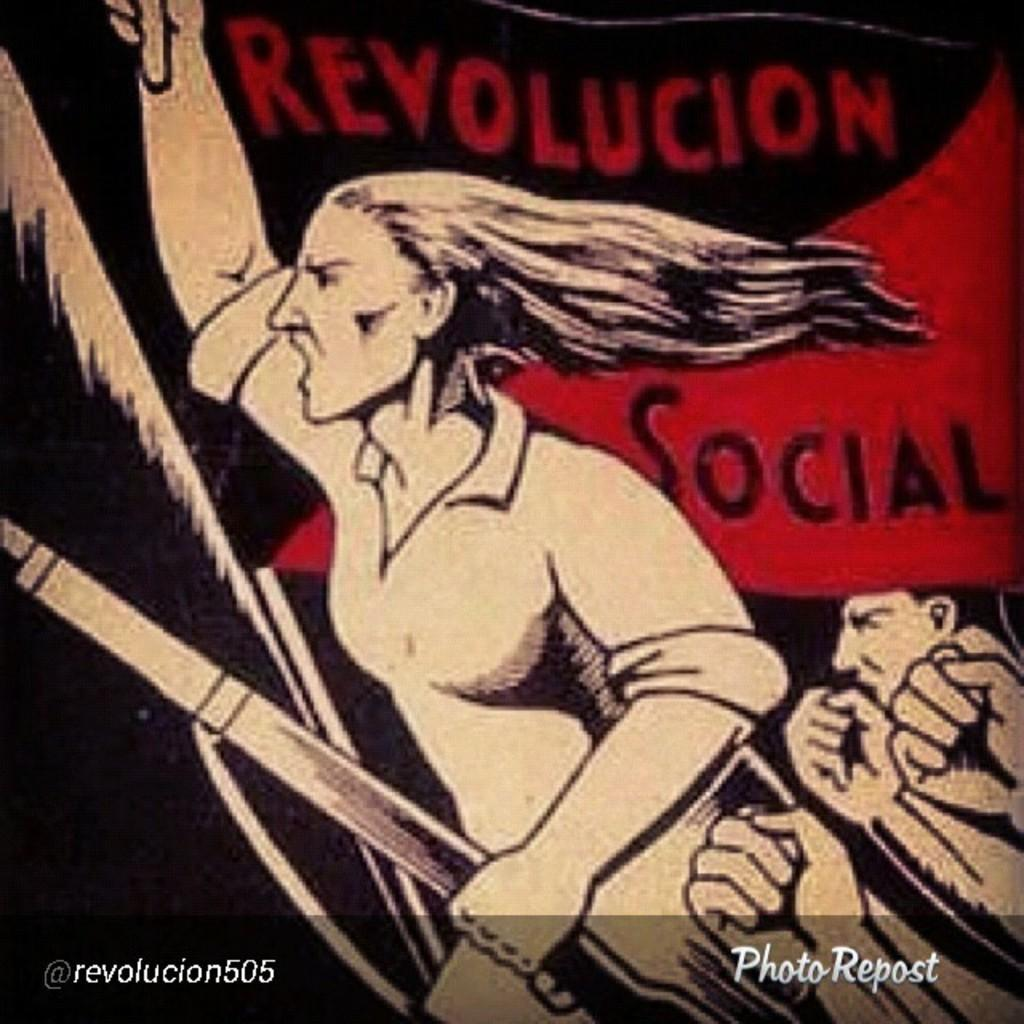<image>
Present a compact description of the photo's key features. A large woman carries a rifle in one hand and has her other arm raised high in an image calling for Revolucion Social. 